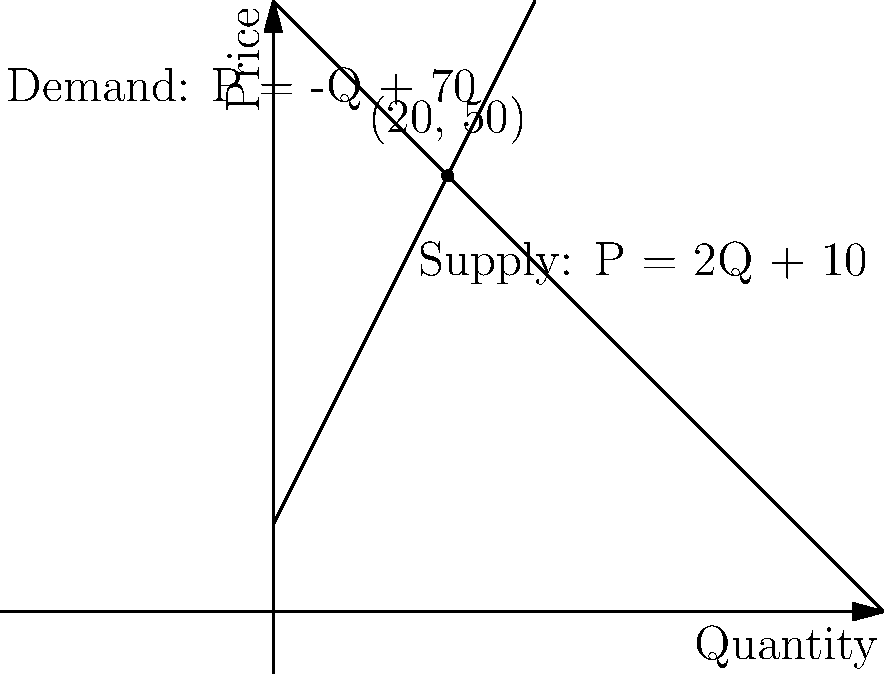As a local business owner, you're analyzing the market for your product. The supply and demand lines for your product are given by the equations:

Supply: $P = 2Q + 10$
Demand: $P = -Q + 70$

Where $P$ is the price and $Q$ is the quantity. At what quantity should you produce to maximize your profit, and what will be the corresponding price? To find the optimal quantity and price, we need to find the intersection point of the supply and demand lines. This point represents market equilibrium where supply meets demand.

Step 1: Set the two equations equal to each other:
$2Q + 10 = -Q + 70$

Step 2: Solve for Q:
$3Q = 60$
$Q = 20$

Step 3: Calculate the corresponding price by substituting Q = 20 into either equation:
$P = 2(20) + 10 = 50$ or $P = -20 + 70 = 50$

Step 4: Verify the result on the graph. The intersection point (20, 50) represents the equilibrium quantity and price.

Therefore, to maximize profit, you should produce 20 units at a price of $50 per unit.
Answer: 20 units at $50 per unit 